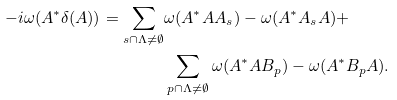Convert formula to latex. <formula><loc_0><loc_0><loc_500><loc_500>- i \omega ( A ^ { * } \delta ( A ) ) = \sum _ { s \cap \Lambda \neq \emptyset } & \omega ( A ^ { * } A A _ { s } ) - \omega ( A ^ { * } A _ { s } A ) + \\ & \sum _ { p \cap \Lambda \neq \emptyset } \omega ( A ^ { * } A B _ { p } ) - \omega ( A ^ { * } B _ { p } A ) .</formula> 